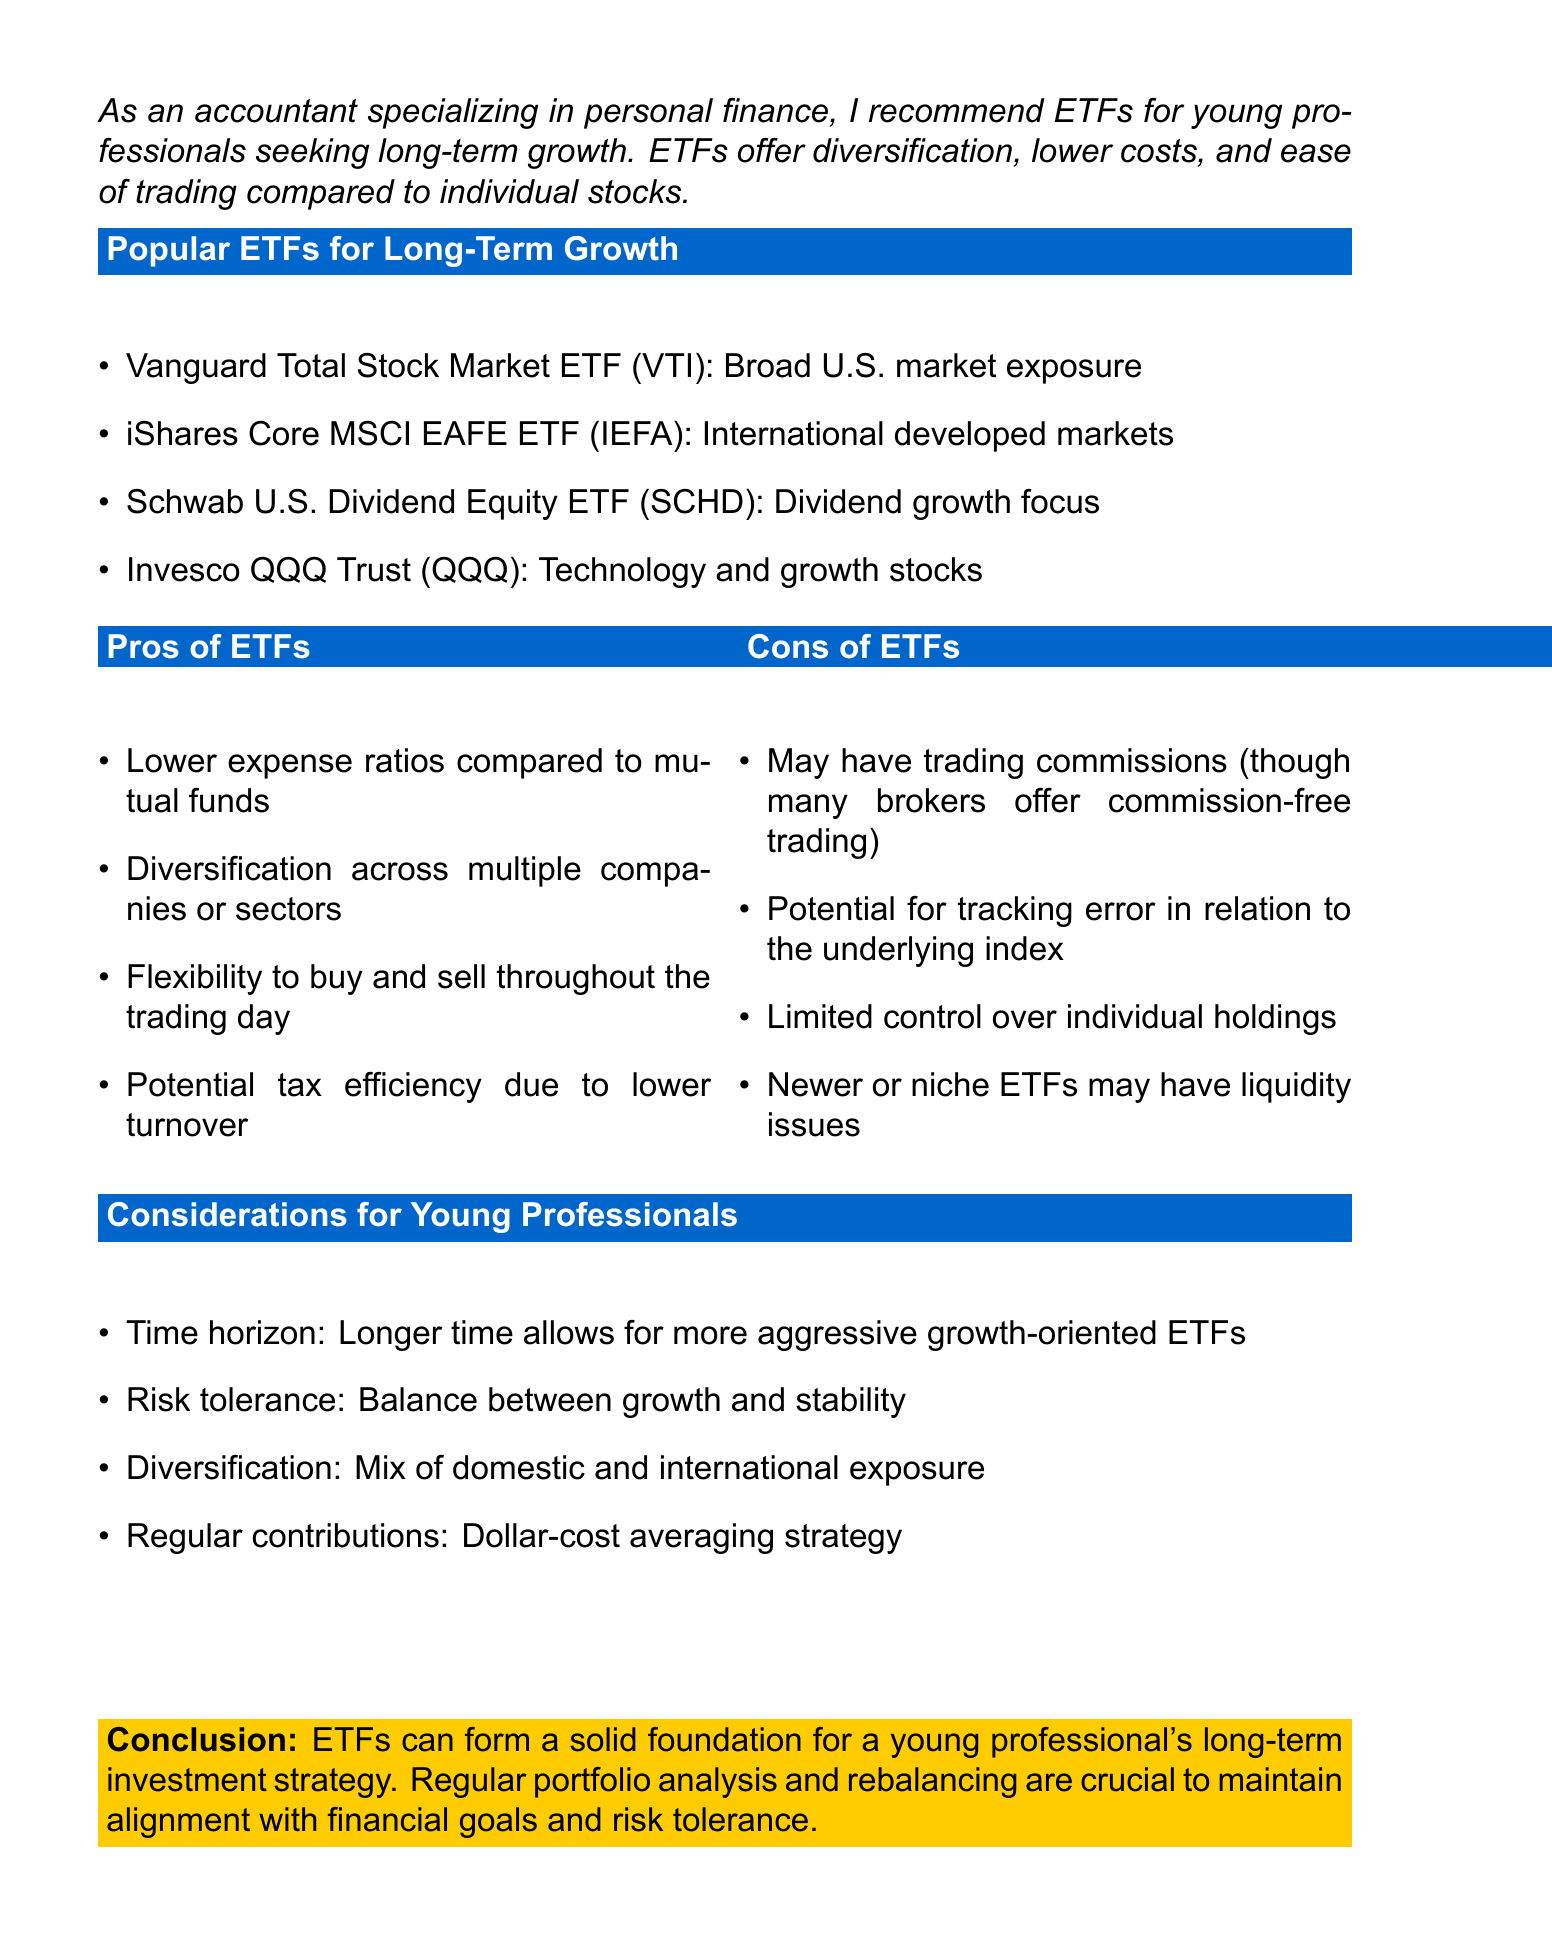What is the title of the document? The title, as stated at the beginning, is "Investment Portfolio Analysis: ETFs for Young Professionals' Long-Term Growth."
Answer: Investment Portfolio Analysis: ETFs for Young Professionals' Long-Term Growth Which ETF focuses on dividend growth? The document lists the Schwab U.S. Dividend Equity ETF as focusing on dividend growth.
Answer: Schwab U.S. Dividend Equity ETF (SCHD) What is one advantage of ETFs mentioned in the document? The pros section lists several advantages, including "Lower expense ratios compared to mutual funds."
Answer: Lower expense ratios compared to mutual funds What is a potential disadvantage of newer ETFs? The document mentions "Newer or niche ETFs may have liquidity issues" as a downside.
Answer: Liquidity issues What should young professionals consider regarding investment time horizon? The document states that a longer time horizon allows for more aggressive growth-oriented ETFs.
Answer: Longer time allows for more aggressive growth-oriented ETFs What is the recommended strategy for contributions mentioned in the document? The document advises a "Dollar-cost averaging strategy" for regular contributions.
Answer: Dollar-cost averaging strategy What are the two types of exposure suggested for diversification in the document? The document suggests a mix of domestic and international exposure for diversification.
Answer: Domestic and international exposure What is emphasized as crucial for maintaining alignment with financial goals? The conclusion states that "Regular portfolio analysis and rebalancing are crucial."
Answer: Regular portfolio analysis and rebalancing 